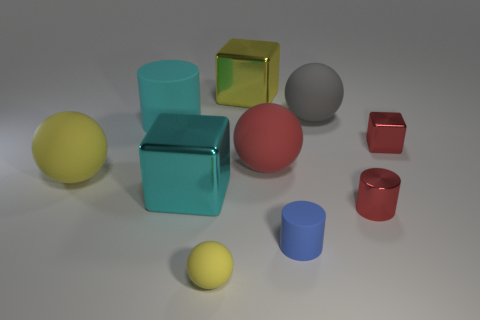Do the big shiny object that is in front of the small red shiny block and the tiny metallic block have the same color?
Offer a terse response. No. Is the cyan cylinder the same size as the red shiny cylinder?
Make the answer very short. No. There is a yellow rubber thing that is the same size as the red block; what is its shape?
Keep it short and to the point. Sphere. There is a yellow rubber object on the right side of the cyan cylinder; is its size the same as the small cube?
Ensure brevity in your answer.  Yes. There is a cyan cylinder that is the same size as the gray rubber ball; what material is it?
Your answer should be compact. Rubber. Is there a big gray matte object right of the large block that is in front of the rubber cylinder on the left side of the big red matte thing?
Your answer should be compact. Yes. Is there any other thing that has the same shape as the gray thing?
Your response must be concise. Yes. There is a thing that is to the left of the large matte cylinder; is its color the same as the big metallic thing that is behind the big yellow matte object?
Your answer should be compact. Yes. Are any cyan metal objects visible?
Your answer should be compact. Yes. There is a large block that is the same color as the small ball; what material is it?
Offer a very short reply. Metal. 